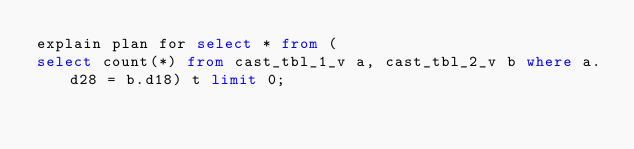<code> <loc_0><loc_0><loc_500><loc_500><_SQL_>explain plan for select * from (
select count(*) from cast_tbl_1_v a, cast_tbl_2_v b where a.d28 = b.d18) t limit 0;
</code> 